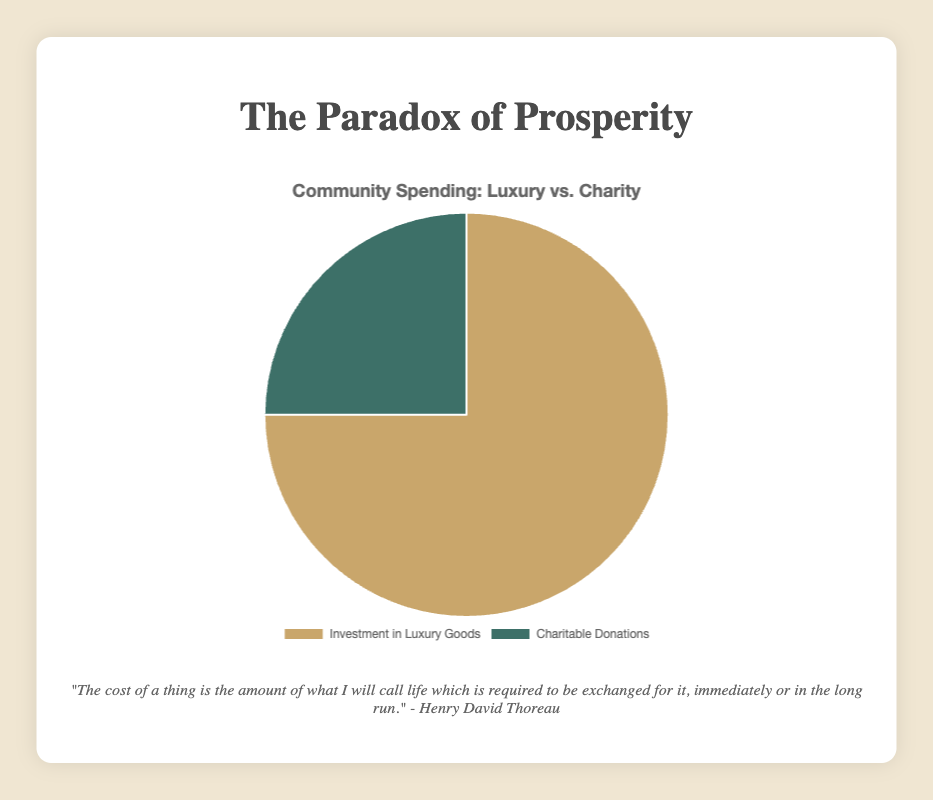Which category has the largest investment? The chart clearly shows that the 'Investment in Luxury Goods' section occupies a larger portion of the pie chart compared to 'Charitable Donations'.
Answer: Investment in Luxury Goods What is the ratio of investment in luxury goods to charitable donations? The exact amounts are provided in the data: $450,000 for luxury goods and $150,000 for charitable donations. The ratio is calculated as 450,000 / 150,000.
Answer: 3:1 What percentage of the total investment is allocated to charitable donations? Total investment is $450,000 (luxury) + $150,000 (charitable). The percentage for charitable donations is (150,000 / 600,000) * 100.
Answer: 25% How much more is invested in luxury goods compared to charitable donations? The difference can be calculated as $450,000 (luxury) - $150,000 (charitable).
Answer: $300,000 If the total investment were to be equally divided, how much would be allocated to each category? Total investment is $600,000. If equally divided, each category would get half of this amount, calculated as 600,000 / 2.
Answer: $300,000 per category 